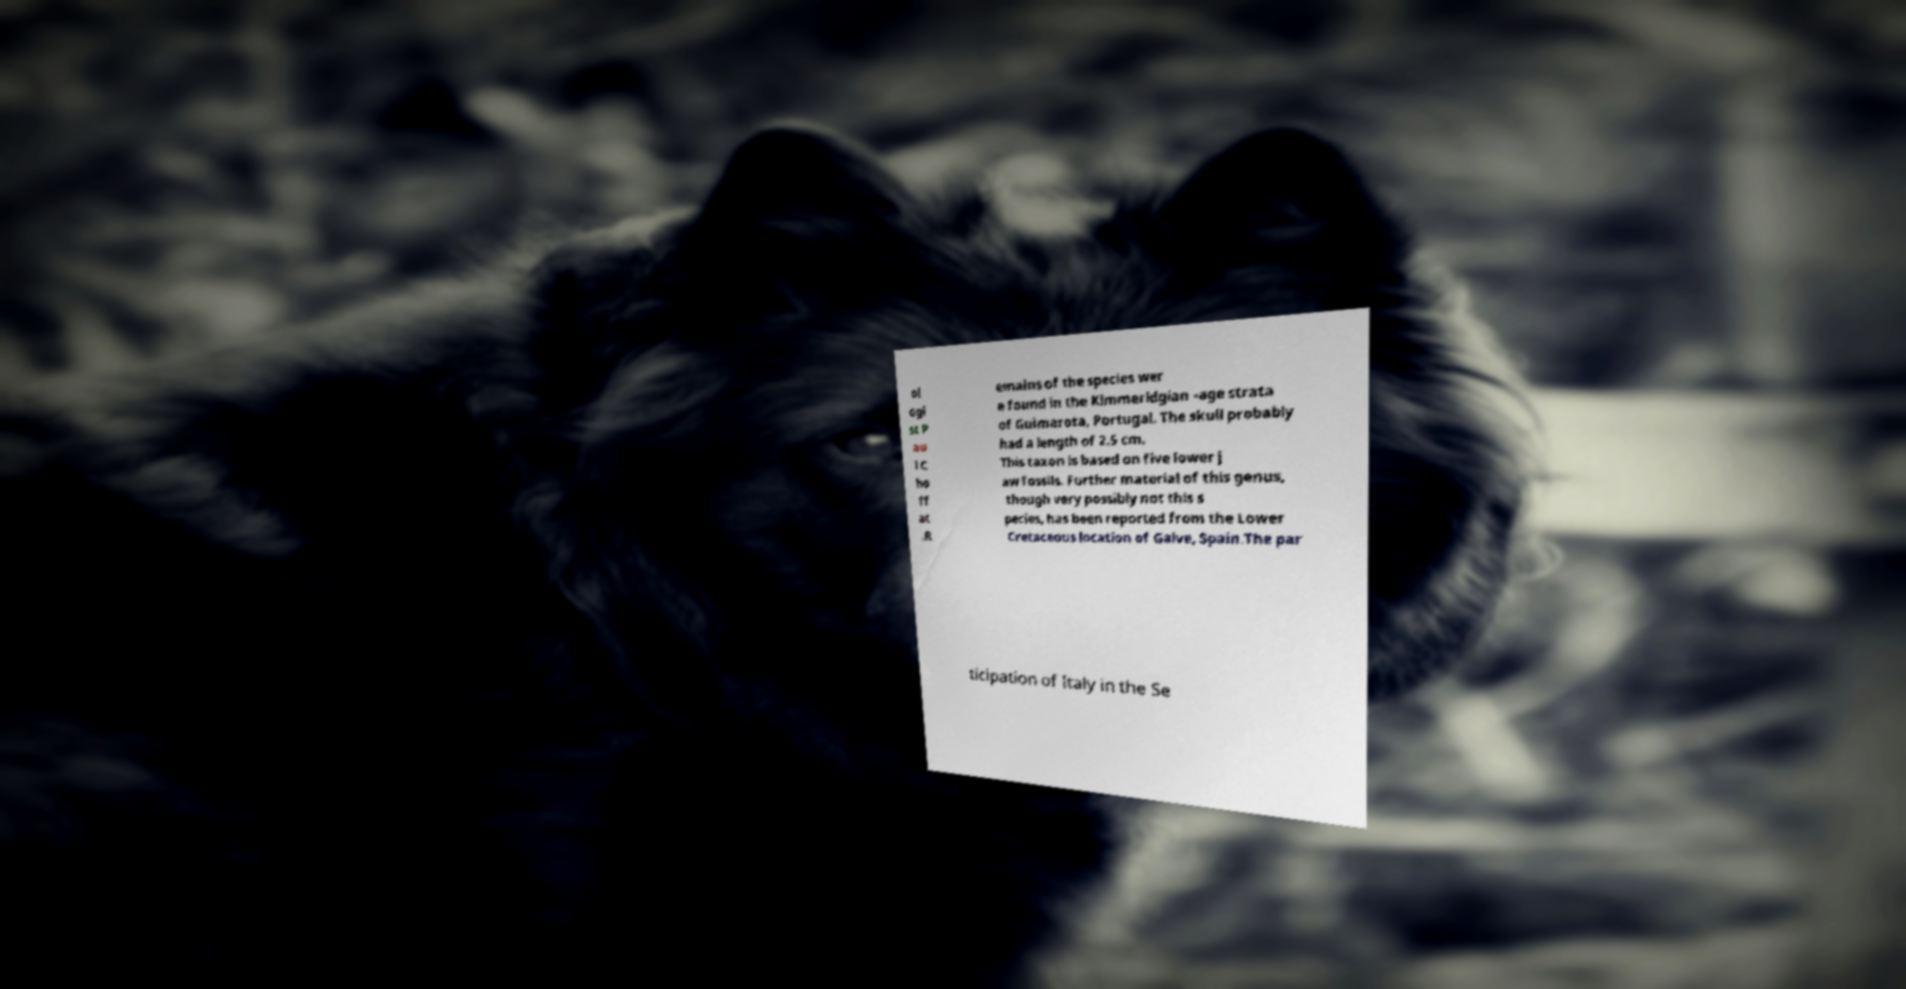I need the written content from this picture converted into text. Can you do that? ol ogi st P au l C ho ff at .R emains of the species wer e found in the Kimmeridgian -age strata of Guimarota, Portugal. The skull probably had a length of 2.5 cm. This taxon is based on five lower j aw fossils. Further material of this genus, though very possibly not this s pecies, has been reported from the Lower Cretaceous location of Galve, Spain.The par ticipation of Italy in the Se 